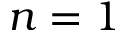<formula> <loc_0><loc_0><loc_500><loc_500>n = 1</formula> 